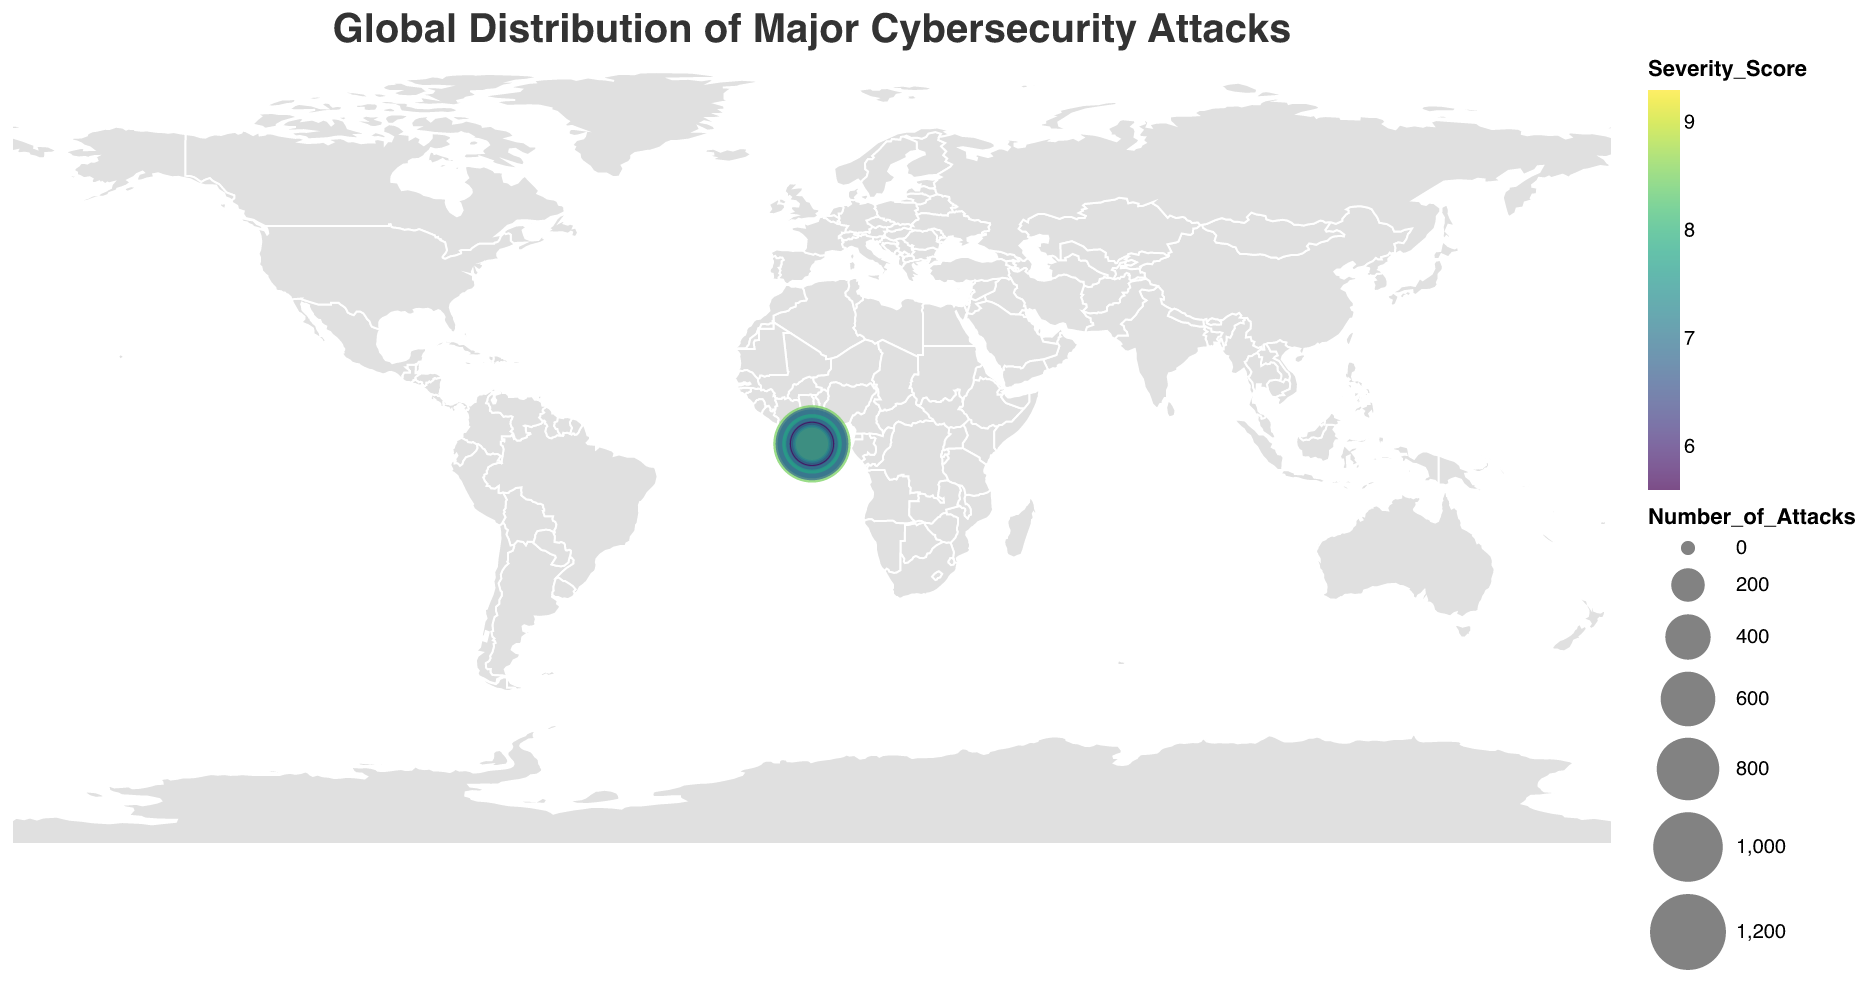How many types of cybersecurity attacks are represented in the figure? The figure lists each country along with the type of cybersecurity attack they experienced. By counting the unique attack types mentioned, we can determine the total number of distinct attack types.
Answer: 15 Which country experienced the highest number of cybersecurity attacks? By examining the size of the circles on the map, we can see that the United States has the largest circle, indicating the highest number of attacks.
Answer: United States What type of attack has the highest severity score and which country was affected by it? By reviewing the colors representing severity scores, the darkest color corresponds to the highest score. We then check which type of attack this highest severity score is associated with, noting the affected country.
Answer: AI-Powered Attack, Israel Compare the number of DDoS attacks in China with Ransomware attacks in the United States. Which is higher? The number of DDoS attacks in China is 980 and the number of Ransomware attacks in the United States is 1250. Comparing these values shows that Ransomware attacks in the United States are higher.
Answer: Ransomware in the United States What's the total number of attacks across Germany and Australia? Summing up the number of attacks for Germany (580) and Australia (410) gives a total.
Answer: 990 What is the average severity score of attacks in India and Singapore? The severity score for India is 8.9 and for Singapore is 8.2. The average can be calculated using (8.9 + 8.2) / 2.
Answer: 8.55 Which country experienced the fewest attacks, and what was the type of attack? By looking at the circle sizes, the smallest circle represents the fewest attacks. Conferring with the data, we find that Israel experienced the fewest attacks with AI-Powered Attack.
Answer: Israel, AI-Powered Attack Identify the attack type with the highest cumulative severity score across all countries. Summing up the severity scores for each attack type across all countries and comparing these sums identifies which attack type has the highest cumulative score.
Answer: Supply Chain Compare the number of Phishing attacks in Russia with the number of Social Engineering attacks in the Netherlands. Which is less? Russia has 1100 Phishing attacks, while the Netherlands has 340 Social Engineering attacks. Thus, Social Engineering attacks in the Netherlands are fewer.
Answer: Social Engineering in the Netherlands Which region in the world (North America, Europe, Asia, etc.) has the most varied attack types represented? By grouping the data by regions and counting the unique types of attack in each region, we determine which region has the most varied attack types.
Answer: Europe 